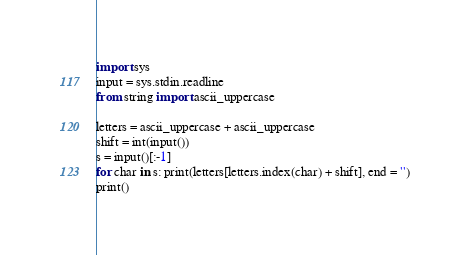<code> <loc_0><loc_0><loc_500><loc_500><_Python_>import sys
input = sys.stdin.readline
from string import ascii_uppercase

letters = ascii_uppercase + ascii_uppercase
shift = int(input())
s = input()[:-1]
for char in s: print(letters[letters.index(char) + shift], end = '')
print()</code> 